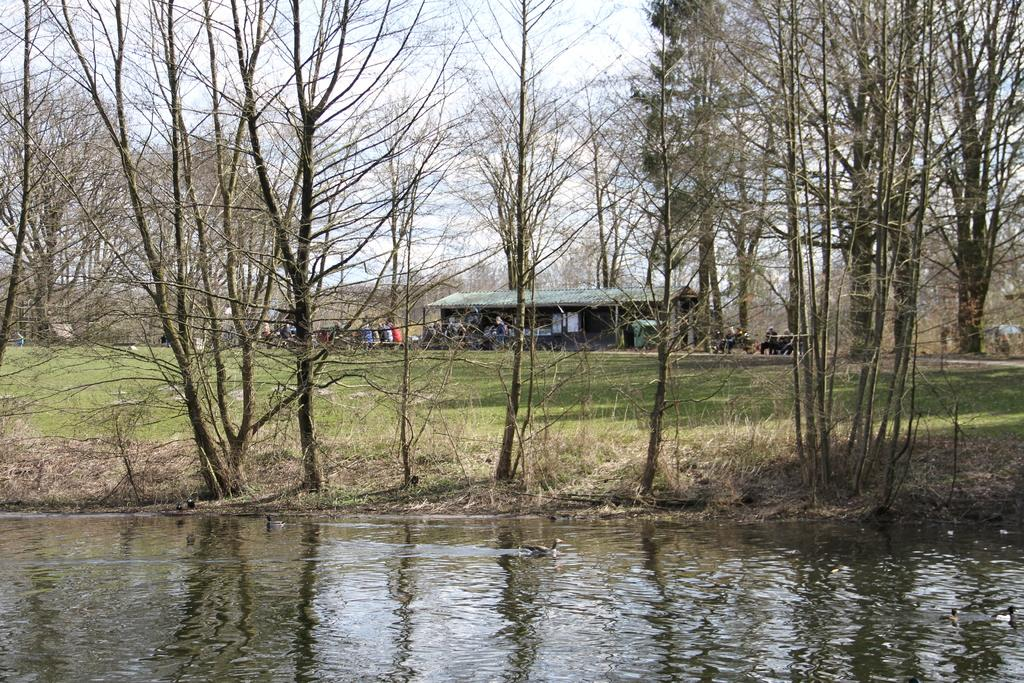What type of animals can be seen in the image? Birds can be seen in the image. What is the primary element in which the birds are situated? The birds are situated in water. What type of vegetation is visible in the image? Trees and grass can be seen in the image. Are there any people present in the image? Yes, there are people in the background of the image. What is the gender of the person depicted in the image? The image includes a depiction of a female (she). What part of the natural environment is visible in the image? The sky is visible in the image. What type of beef can be seen hanging from the trees in the image? There is no beef present in the image; it features birds in water, trees, grass, people, and a female figure. Can you see any toys in the image? There are no toys visible in the image. 